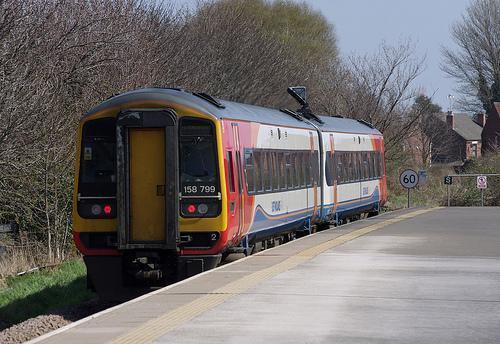How many train cars are there?
Give a very brief answer. 2. 